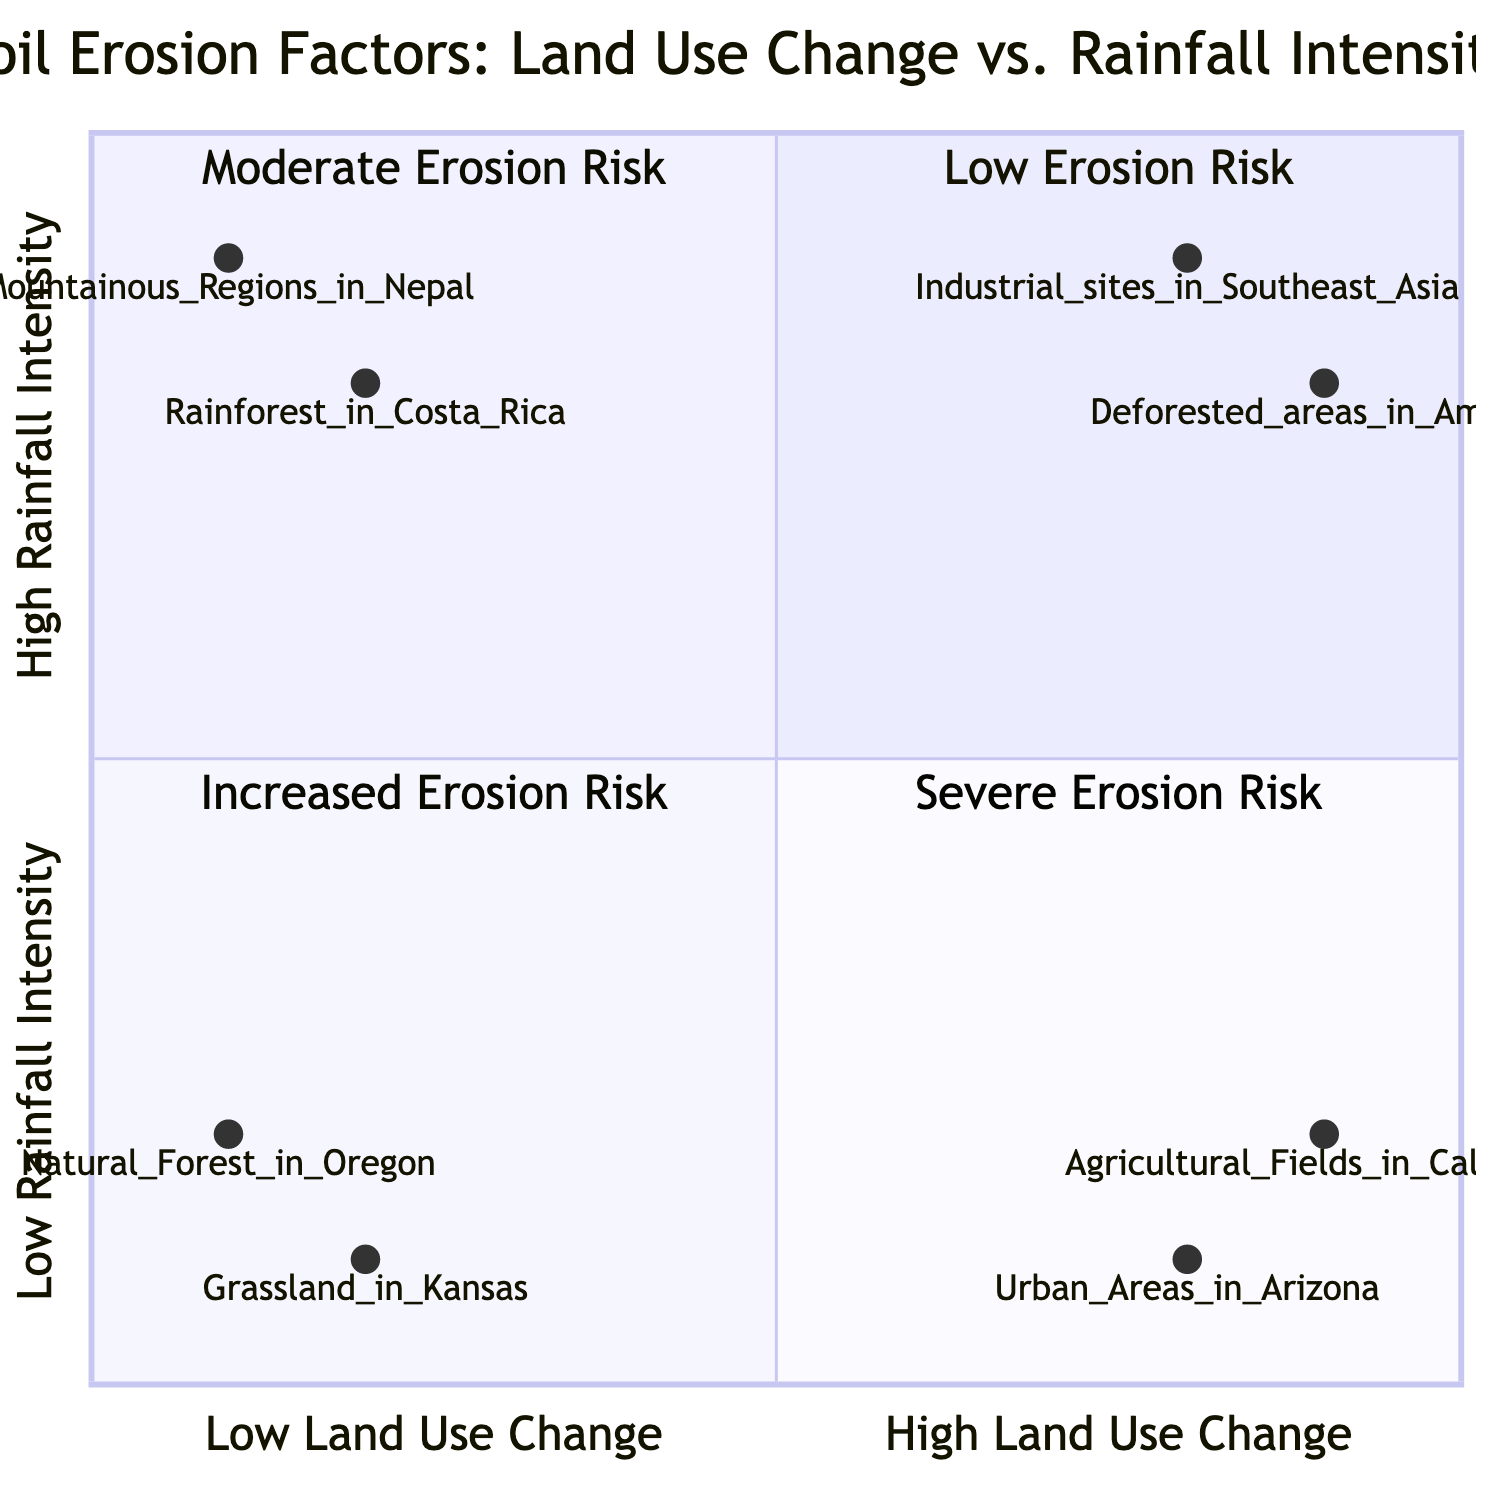What example falls into the category of High Land Use Change - Low Rainfall Intensity? The quadrant labeled "High Land Use Change - Low Rainfall Intensity" lists "Urban Areas in Arizona" and "Agricultural Fields in California." Therefore, any of these would be correct answers.
Answer: Urban Areas in Arizona What characteristics are associated with the Low Land Use Change - High Rainfall Intensity quadrant? This quadrant shows characteristics that include "Dense vegetation provides protection," "Natural terrain adjustments," and "Moderate soil erosion." These aspects are specifically described under that quadrant.
Answer: Dense vegetation provides protection How many examples are found in the High Land Use Change - High Rainfall Intensity quadrant? The quadrant lists two examples: "Deforested areas in the Amazon Basin" and "Industrial sites in Southeast Asia," which means there are two examples in total.
Answer: 2 What is the erosion risk in the Low Land Use Change - Low Rainfall Intensity quadrant? The quadrant refers to "Low Erosion Risk," indicating that soil erosion is minimal under these conditions.
Answer: Low Erosion Risk Which quadrant characterizes areas with both high land use change and high rainfall intensity? The quadrant titled "High Land Use Change - High Rainfall Intensity" specifically describes areas that have this combination of factors, as indicated in the chart.
Answer: High Land Use Change - High Rainfall Intensity What is the rainfall intensity level in the Low Land Use Change - High Rainfall Intensity quadrant? The characteristic data for this quadrant indicates that the rainfall intensity level is high, as specified in the title of that quadrant.
Answer: High What relationship can be inferred between Land Use Change and Soil Erosion Risk? The diagram suggests that as land use change increases alongside rainfall intensity (especially in the "High Land Use Change - High Rainfall Intensity" quadrant), the soil erosion risk becomes severe. This indicates a direct relationship between the two factors concerning erosion risk.
Answer: Direct relationship Which terrain is an example of a Low Land Use Change - High Rainfall Intensity area? Under this quadrant, "Mountainous Regions in Nepal" is provided as an example. Therefore, this location appropriately fits the criteria indicated in the question.
Answer: Mountainous Regions in Nepal 